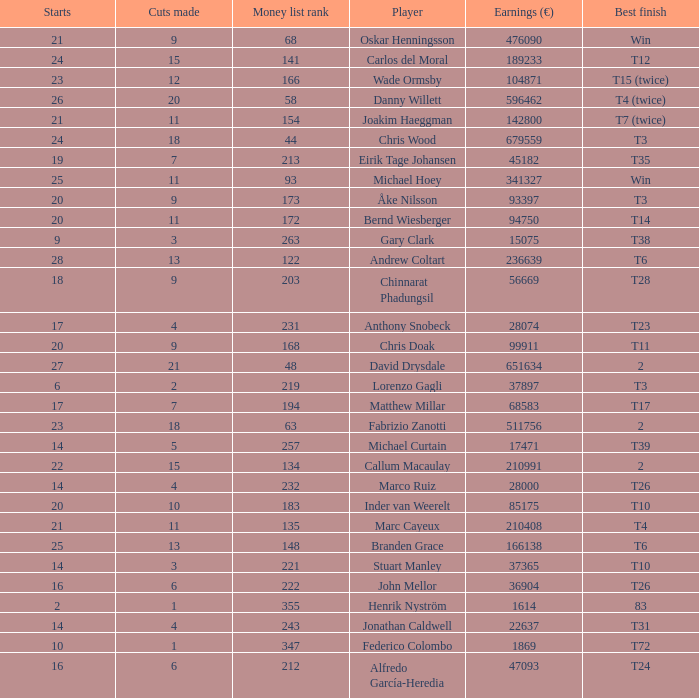Which player made exactly 26 starts? Danny Willett. 